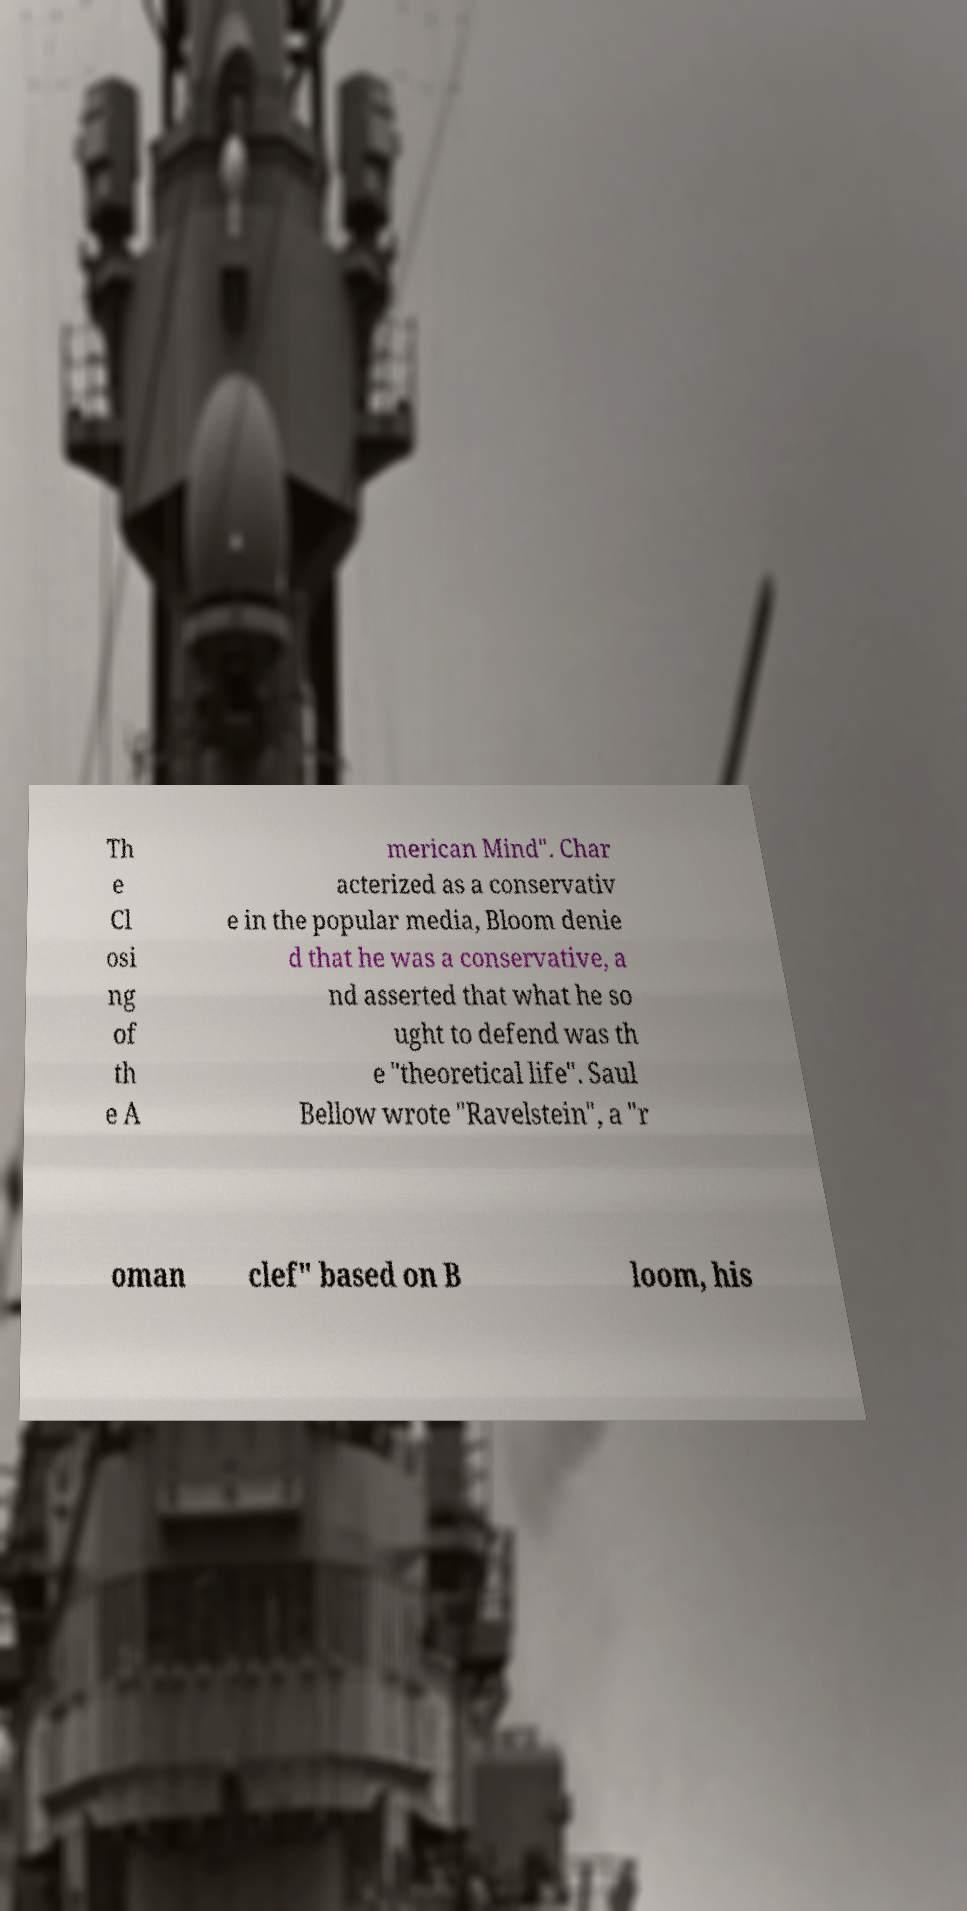I need the written content from this picture converted into text. Can you do that? Th e Cl osi ng of th e A merican Mind". Char acterized as a conservativ e in the popular media, Bloom denie d that he was a conservative, a nd asserted that what he so ught to defend was th e "theoretical life". Saul Bellow wrote "Ravelstein", a "r oman clef" based on B loom, his 